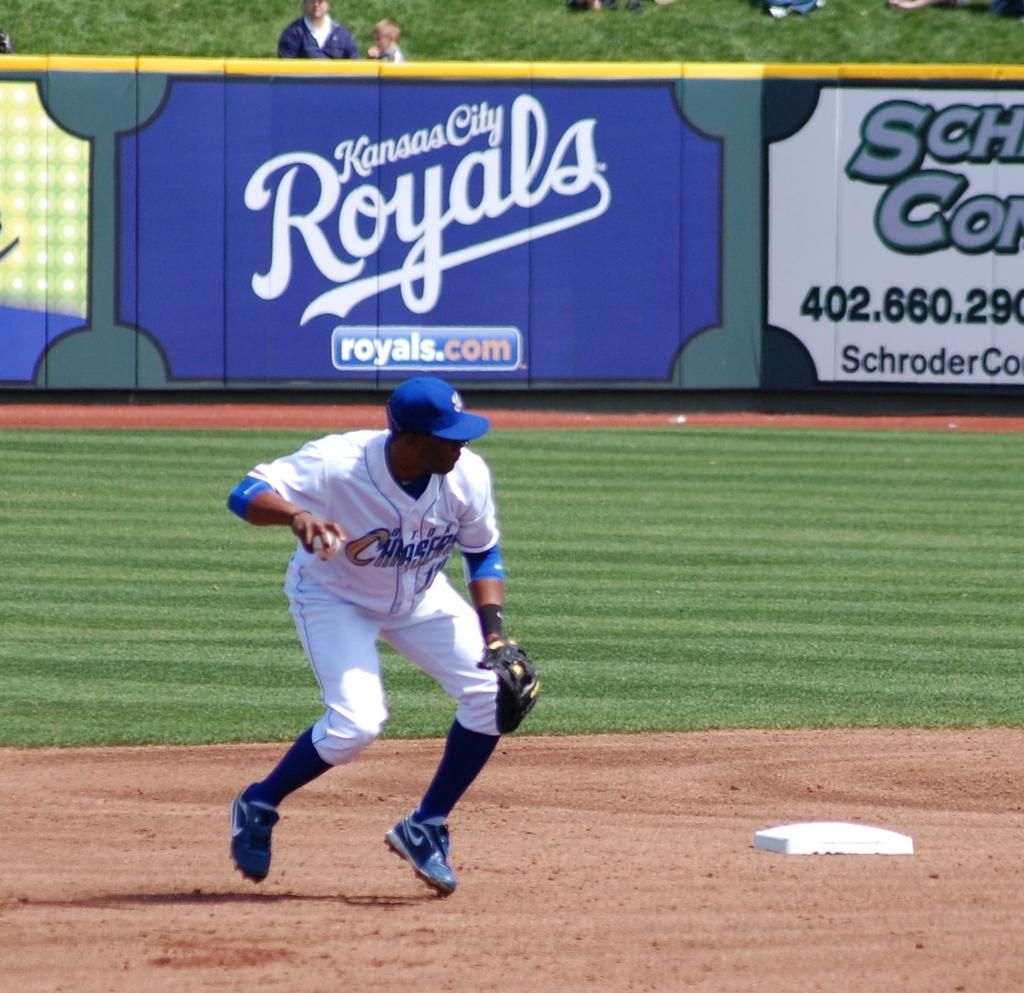<image>
Write a terse but informative summary of the picture. Baseball player playing in front of a sign which says Kansas City Royals. 